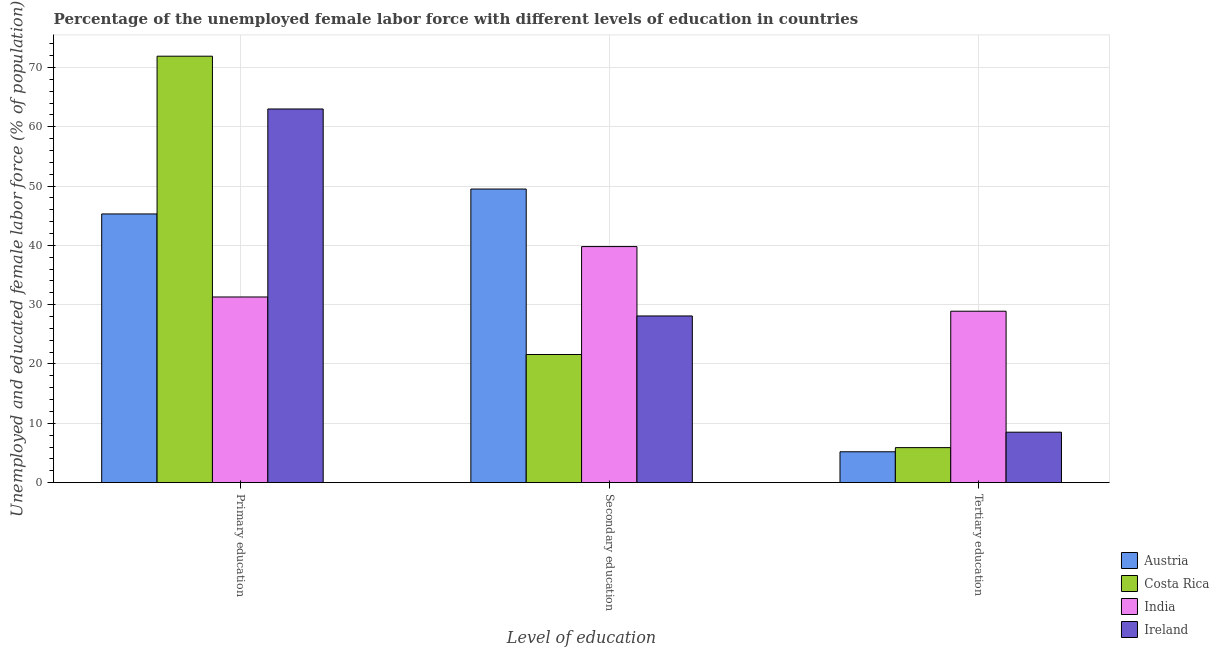How many different coloured bars are there?
Offer a very short reply. 4. How many groups of bars are there?
Provide a short and direct response. 3. Are the number of bars per tick equal to the number of legend labels?
Your answer should be compact. Yes. What is the label of the 3rd group of bars from the left?
Your answer should be compact. Tertiary education. What is the percentage of female labor force who received primary education in Costa Rica?
Provide a succinct answer. 71.9. Across all countries, what is the maximum percentage of female labor force who received tertiary education?
Your response must be concise. 28.9. Across all countries, what is the minimum percentage of female labor force who received primary education?
Offer a very short reply. 31.3. In which country was the percentage of female labor force who received tertiary education maximum?
Your answer should be very brief. India. In which country was the percentage of female labor force who received primary education minimum?
Your response must be concise. India. What is the total percentage of female labor force who received primary education in the graph?
Make the answer very short. 211.5. What is the difference between the percentage of female labor force who received secondary education in Austria and that in India?
Ensure brevity in your answer.  9.7. What is the difference between the percentage of female labor force who received primary education in Ireland and the percentage of female labor force who received secondary education in Costa Rica?
Your answer should be compact. 41.4. What is the average percentage of female labor force who received primary education per country?
Keep it short and to the point. 52.87. What is the difference between the percentage of female labor force who received primary education and percentage of female labor force who received secondary education in India?
Provide a short and direct response. -8.5. In how many countries, is the percentage of female labor force who received secondary education greater than 30 %?
Give a very brief answer. 2. What is the ratio of the percentage of female labor force who received tertiary education in Ireland to that in Costa Rica?
Ensure brevity in your answer.  1.44. Is the difference between the percentage of female labor force who received tertiary education in Austria and India greater than the difference between the percentage of female labor force who received secondary education in Austria and India?
Provide a succinct answer. No. What is the difference between the highest and the second highest percentage of female labor force who received primary education?
Keep it short and to the point. 8.9. What is the difference between the highest and the lowest percentage of female labor force who received tertiary education?
Give a very brief answer. 23.7. What does the 1st bar from the left in Primary education represents?
Offer a very short reply. Austria. How many bars are there?
Make the answer very short. 12. Are all the bars in the graph horizontal?
Give a very brief answer. No. What is the difference between two consecutive major ticks on the Y-axis?
Your answer should be very brief. 10. Are the values on the major ticks of Y-axis written in scientific E-notation?
Ensure brevity in your answer.  No. Does the graph contain any zero values?
Provide a succinct answer. No. Does the graph contain grids?
Make the answer very short. Yes. How are the legend labels stacked?
Keep it short and to the point. Vertical. What is the title of the graph?
Your answer should be very brief. Percentage of the unemployed female labor force with different levels of education in countries. What is the label or title of the X-axis?
Give a very brief answer. Level of education. What is the label or title of the Y-axis?
Offer a very short reply. Unemployed and educated female labor force (% of population). What is the Unemployed and educated female labor force (% of population) of Austria in Primary education?
Provide a short and direct response. 45.3. What is the Unemployed and educated female labor force (% of population) in Costa Rica in Primary education?
Keep it short and to the point. 71.9. What is the Unemployed and educated female labor force (% of population) of India in Primary education?
Your answer should be very brief. 31.3. What is the Unemployed and educated female labor force (% of population) of Austria in Secondary education?
Your answer should be compact. 49.5. What is the Unemployed and educated female labor force (% of population) in Costa Rica in Secondary education?
Provide a succinct answer. 21.6. What is the Unemployed and educated female labor force (% of population) in India in Secondary education?
Provide a short and direct response. 39.8. What is the Unemployed and educated female labor force (% of population) in Ireland in Secondary education?
Ensure brevity in your answer.  28.1. What is the Unemployed and educated female labor force (% of population) of Austria in Tertiary education?
Provide a short and direct response. 5.2. What is the Unemployed and educated female labor force (% of population) in Costa Rica in Tertiary education?
Offer a very short reply. 5.9. What is the Unemployed and educated female labor force (% of population) in India in Tertiary education?
Keep it short and to the point. 28.9. Across all Level of education, what is the maximum Unemployed and educated female labor force (% of population) in Austria?
Make the answer very short. 49.5. Across all Level of education, what is the maximum Unemployed and educated female labor force (% of population) in Costa Rica?
Make the answer very short. 71.9. Across all Level of education, what is the maximum Unemployed and educated female labor force (% of population) of India?
Provide a short and direct response. 39.8. Across all Level of education, what is the maximum Unemployed and educated female labor force (% of population) in Ireland?
Your response must be concise. 63. Across all Level of education, what is the minimum Unemployed and educated female labor force (% of population) of Austria?
Your answer should be very brief. 5.2. Across all Level of education, what is the minimum Unemployed and educated female labor force (% of population) in Costa Rica?
Offer a terse response. 5.9. Across all Level of education, what is the minimum Unemployed and educated female labor force (% of population) in India?
Provide a short and direct response. 28.9. What is the total Unemployed and educated female labor force (% of population) in Costa Rica in the graph?
Make the answer very short. 99.4. What is the total Unemployed and educated female labor force (% of population) of Ireland in the graph?
Your response must be concise. 99.6. What is the difference between the Unemployed and educated female labor force (% of population) of Austria in Primary education and that in Secondary education?
Ensure brevity in your answer.  -4.2. What is the difference between the Unemployed and educated female labor force (% of population) of Costa Rica in Primary education and that in Secondary education?
Offer a very short reply. 50.3. What is the difference between the Unemployed and educated female labor force (% of population) of India in Primary education and that in Secondary education?
Offer a terse response. -8.5. What is the difference between the Unemployed and educated female labor force (% of population) in Ireland in Primary education and that in Secondary education?
Provide a succinct answer. 34.9. What is the difference between the Unemployed and educated female labor force (% of population) in Austria in Primary education and that in Tertiary education?
Offer a terse response. 40.1. What is the difference between the Unemployed and educated female labor force (% of population) in India in Primary education and that in Tertiary education?
Make the answer very short. 2.4. What is the difference between the Unemployed and educated female labor force (% of population) of Ireland in Primary education and that in Tertiary education?
Offer a very short reply. 54.5. What is the difference between the Unemployed and educated female labor force (% of population) of Austria in Secondary education and that in Tertiary education?
Give a very brief answer. 44.3. What is the difference between the Unemployed and educated female labor force (% of population) of Costa Rica in Secondary education and that in Tertiary education?
Provide a succinct answer. 15.7. What is the difference between the Unemployed and educated female labor force (% of population) of Ireland in Secondary education and that in Tertiary education?
Make the answer very short. 19.6. What is the difference between the Unemployed and educated female labor force (% of population) in Austria in Primary education and the Unemployed and educated female labor force (% of population) in Costa Rica in Secondary education?
Provide a short and direct response. 23.7. What is the difference between the Unemployed and educated female labor force (% of population) of Costa Rica in Primary education and the Unemployed and educated female labor force (% of population) of India in Secondary education?
Offer a terse response. 32.1. What is the difference between the Unemployed and educated female labor force (% of population) of Costa Rica in Primary education and the Unemployed and educated female labor force (% of population) of Ireland in Secondary education?
Give a very brief answer. 43.8. What is the difference between the Unemployed and educated female labor force (% of population) of India in Primary education and the Unemployed and educated female labor force (% of population) of Ireland in Secondary education?
Your answer should be very brief. 3.2. What is the difference between the Unemployed and educated female labor force (% of population) of Austria in Primary education and the Unemployed and educated female labor force (% of population) of Costa Rica in Tertiary education?
Offer a very short reply. 39.4. What is the difference between the Unemployed and educated female labor force (% of population) in Austria in Primary education and the Unemployed and educated female labor force (% of population) in India in Tertiary education?
Offer a very short reply. 16.4. What is the difference between the Unemployed and educated female labor force (% of population) in Austria in Primary education and the Unemployed and educated female labor force (% of population) in Ireland in Tertiary education?
Your answer should be compact. 36.8. What is the difference between the Unemployed and educated female labor force (% of population) of Costa Rica in Primary education and the Unemployed and educated female labor force (% of population) of India in Tertiary education?
Your response must be concise. 43. What is the difference between the Unemployed and educated female labor force (% of population) of Costa Rica in Primary education and the Unemployed and educated female labor force (% of population) of Ireland in Tertiary education?
Offer a terse response. 63.4. What is the difference between the Unemployed and educated female labor force (% of population) of India in Primary education and the Unemployed and educated female labor force (% of population) of Ireland in Tertiary education?
Your answer should be very brief. 22.8. What is the difference between the Unemployed and educated female labor force (% of population) of Austria in Secondary education and the Unemployed and educated female labor force (% of population) of Costa Rica in Tertiary education?
Provide a short and direct response. 43.6. What is the difference between the Unemployed and educated female labor force (% of population) of Austria in Secondary education and the Unemployed and educated female labor force (% of population) of India in Tertiary education?
Offer a terse response. 20.6. What is the difference between the Unemployed and educated female labor force (% of population) of Austria in Secondary education and the Unemployed and educated female labor force (% of population) of Ireland in Tertiary education?
Your answer should be compact. 41. What is the difference between the Unemployed and educated female labor force (% of population) of India in Secondary education and the Unemployed and educated female labor force (% of population) of Ireland in Tertiary education?
Offer a terse response. 31.3. What is the average Unemployed and educated female labor force (% of population) of Austria per Level of education?
Offer a very short reply. 33.33. What is the average Unemployed and educated female labor force (% of population) in Costa Rica per Level of education?
Provide a short and direct response. 33.13. What is the average Unemployed and educated female labor force (% of population) of India per Level of education?
Offer a very short reply. 33.33. What is the average Unemployed and educated female labor force (% of population) in Ireland per Level of education?
Provide a short and direct response. 33.2. What is the difference between the Unemployed and educated female labor force (% of population) in Austria and Unemployed and educated female labor force (% of population) in Costa Rica in Primary education?
Your answer should be very brief. -26.6. What is the difference between the Unemployed and educated female labor force (% of population) in Austria and Unemployed and educated female labor force (% of population) in Ireland in Primary education?
Your response must be concise. -17.7. What is the difference between the Unemployed and educated female labor force (% of population) in Costa Rica and Unemployed and educated female labor force (% of population) in India in Primary education?
Make the answer very short. 40.6. What is the difference between the Unemployed and educated female labor force (% of population) in India and Unemployed and educated female labor force (% of population) in Ireland in Primary education?
Provide a succinct answer. -31.7. What is the difference between the Unemployed and educated female labor force (% of population) of Austria and Unemployed and educated female labor force (% of population) of Costa Rica in Secondary education?
Ensure brevity in your answer.  27.9. What is the difference between the Unemployed and educated female labor force (% of population) of Austria and Unemployed and educated female labor force (% of population) of India in Secondary education?
Give a very brief answer. 9.7. What is the difference between the Unemployed and educated female labor force (% of population) in Austria and Unemployed and educated female labor force (% of population) in Ireland in Secondary education?
Provide a short and direct response. 21.4. What is the difference between the Unemployed and educated female labor force (% of population) in Costa Rica and Unemployed and educated female labor force (% of population) in India in Secondary education?
Give a very brief answer. -18.2. What is the difference between the Unemployed and educated female labor force (% of population) in Costa Rica and Unemployed and educated female labor force (% of population) in Ireland in Secondary education?
Your answer should be very brief. -6.5. What is the difference between the Unemployed and educated female labor force (% of population) in Austria and Unemployed and educated female labor force (% of population) in India in Tertiary education?
Provide a succinct answer. -23.7. What is the difference between the Unemployed and educated female labor force (% of population) of Costa Rica and Unemployed and educated female labor force (% of population) of India in Tertiary education?
Provide a short and direct response. -23. What is the difference between the Unemployed and educated female labor force (% of population) in India and Unemployed and educated female labor force (% of population) in Ireland in Tertiary education?
Offer a terse response. 20.4. What is the ratio of the Unemployed and educated female labor force (% of population) of Austria in Primary education to that in Secondary education?
Provide a succinct answer. 0.92. What is the ratio of the Unemployed and educated female labor force (% of population) of Costa Rica in Primary education to that in Secondary education?
Your answer should be compact. 3.33. What is the ratio of the Unemployed and educated female labor force (% of population) of India in Primary education to that in Secondary education?
Offer a very short reply. 0.79. What is the ratio of the Unemployed and educated female labor force (% of population) in Ireland in Primary education to that in Secondary education?
Offer a terse response. 2.24. What is the ratio of the Unemployed and educated female labor force (% of population) of Austria in Primary education to that in Tertiary education?
Provide a short and direct response. 8.71. What is the ratio of the Unemployed and educated female labor force (% of population) of Costa Rica in Primary education to that in Tertiary education?
Offer a terse response. 12.19. What is the ratio of the Unemployed and educated female labor force (% of population) in India in Primary education to that in Tertiary education?
Your answer should be very brief. 1.08. What is the ratio of the Unemployed and educated female labor force (% of population) of Ireland in Primary education to that in Tertiary education?
Your response must be concise. 7.41. What is the ratio of the Unemployed and educated female labor force (% of population) of Austria in Secondary education to that in Tertiary education?
Ensure brevity in your answer.  9.52. What is the ratio of the Unemployed and educated female labor force (% of population) of Costa Rica in Secondary education to that in Tertiary education?
Give a very brief answer. 3.66. What is the ratio of the Unemployed and educated female labor force (% of population) in India in Secondary education to that in Tertiary education?
Ensure brevity in your answer.  1.38. What is the ratio of the Unemployed and educated female labor force (% of population) in Ireland in Secondary education to that in Tertiary education?
Keep it short and to the point. 3.31. What is the difference between the highest and the second highest Unemployed and educated female labor force (% of population) in Austria?
Offer a very short reply. 4.2. What is the difference between the highest and the second highest Unemployed and educated female labor force (% of population) in Costa Rica?
Ensure brevity in your answer.  50.3. What is the difference between the highest and the second highest Unemployed and educated female labor force (% of population) of Ireland?
Offer a very short reply. 34.9. What is the difference between the highest and the lowest Unemployed and educated female labor force (% of population) of Austria?
Give a very brief answer. 44.3. What is the difference between the highest and the lowest Unemployed and educated female labor force (% of population) in Ireland?
Your answer should be compact. 54.5. 